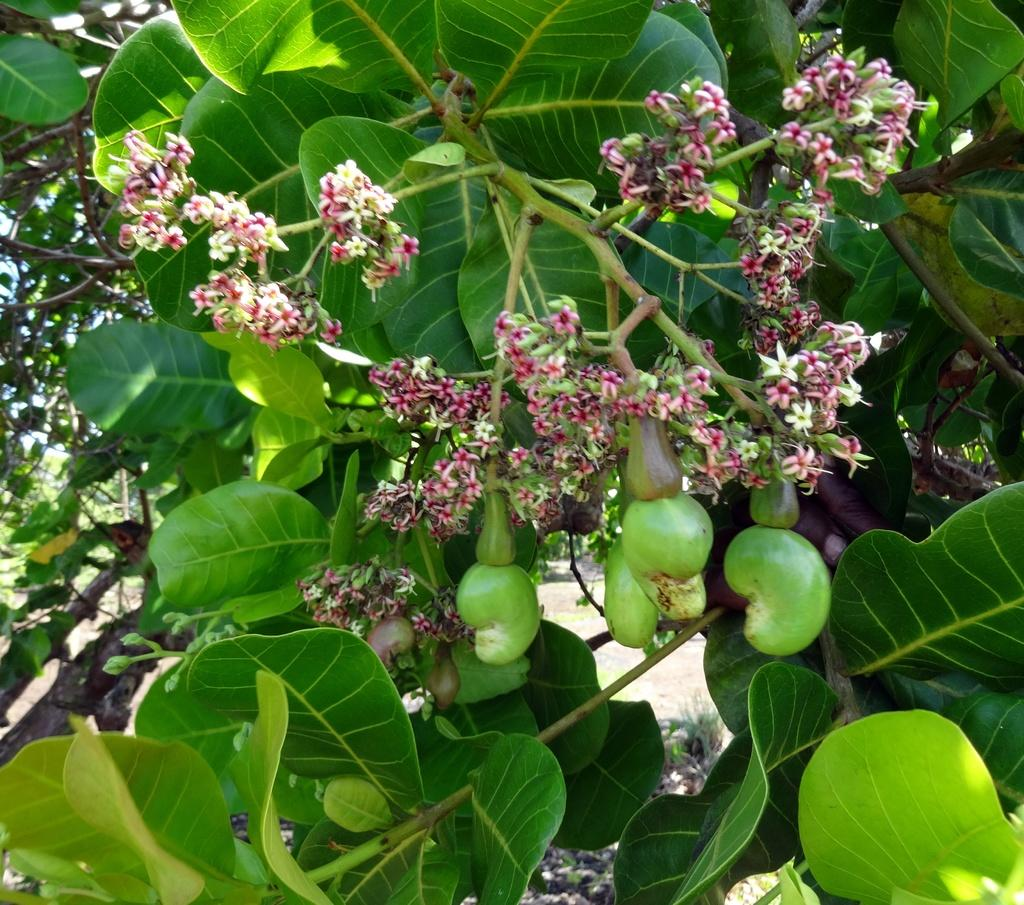What types of plants can be seen in the image? There are flowers and fruits in the image. What else is visible in the image besides the plants? There are leaves of a tree in the image. What type of pie is being served in the image? There is no pie present in the image; it features flowers, fruits, and leaves of a tree. What title is given to the person holding the flowers in the image? There is no person holding flowers in the image; the image only contains plants and leaves. 